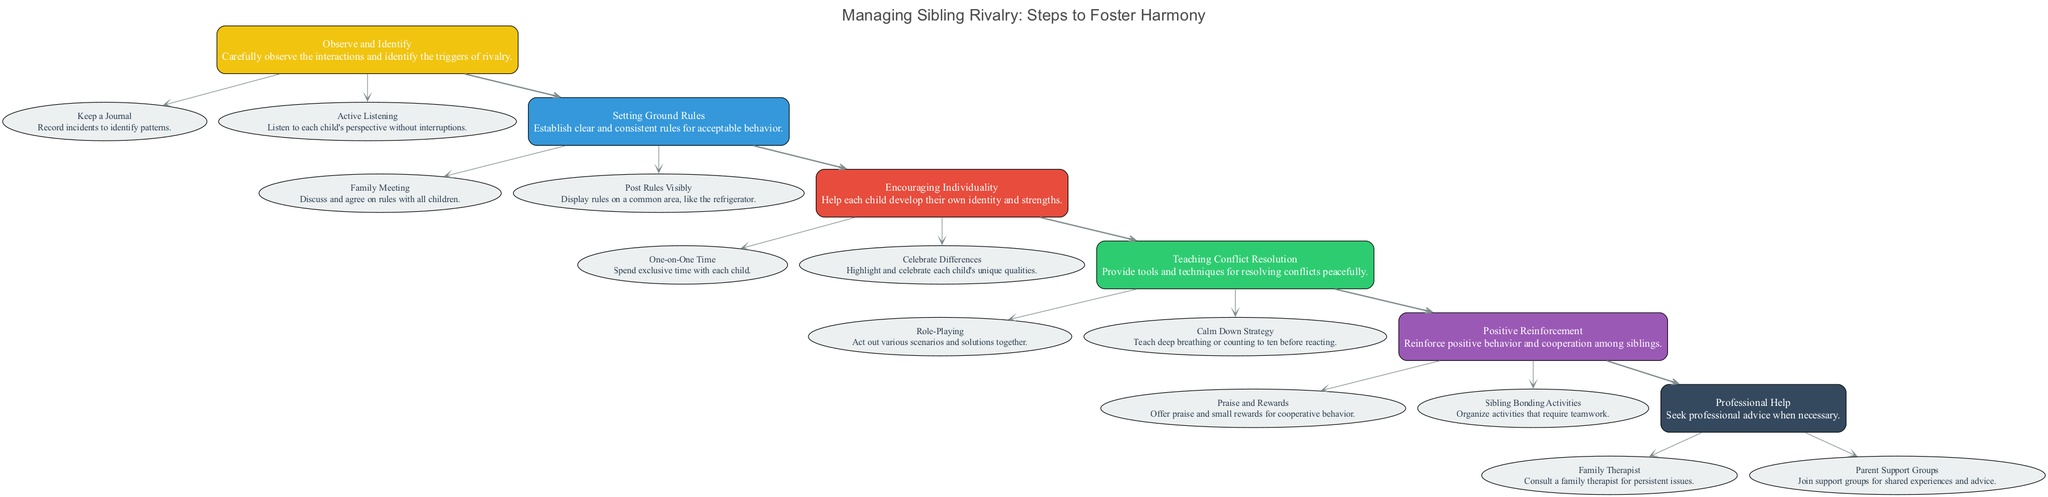What is the first step in the pathway? The first step listed in the diagram is "Observe and Identify," which can be found at the top of the pathway as it flows downward.
Answer: Observe and Identify How many main steps are in the diagram? By counting each distinct box that represents a main step, we find a total of six steps throughout the pathway.
Answer: 6 What action is associated with "Positive Reinforcement"? Under the "Positive Reinforcement" step, two actions are detailed: "Praise and Rewards" and "Sibling Bonding Activities." The question asks for one associated action, so either can be an acceptable answer.
Answer: Praise and Rewards Which step follows "Encouraging Individuality"? The arrow connecting "Encouraging Individuality" points to "Teaching Conflict Resolution." This indicates that it is the next step in the sequence after "Encouraging Individuality."
Answer: Teaching Conflict Resolution What is a suggested action in the "Setting Ground Rules" step? In the "Setting Ground Rules" section, one suggested action is "Family Meeting." This can be identified among the actions listed under that step.
Answer: Family Meeting What should be done if sibling rivalry persists despite other efforts? The diagram indicates that in the case of persistent sibling rivalry, one should seek "Professional Help." This underscores the importance of consulting experts when necessary.
Answer: Professional Help Which action specifically helps children learn to manage emotions in conflicts? The action "Calm Down Strategy" under the "Teaching Conflict Resolution" step provides techniques for children to manage their emotions through methods like deep breathing or counting.
Answer: Calm Down Strategy How many actions are listed under "Encouraging Individuality"? In the "Encouraging Individuality" step, there are two actions: "One-on-One Time" and "Celebrate Differences." Counting these actions gives a total of two.
Answer: 2 What is the primary goal of the "Positive Reinforcement" step? The "Positive Reinforcement" step aims to reinforce positive behavior and cooperation among siblings, which is its main objective as described in the pathway.
Answer: Reinforce positive behavior 